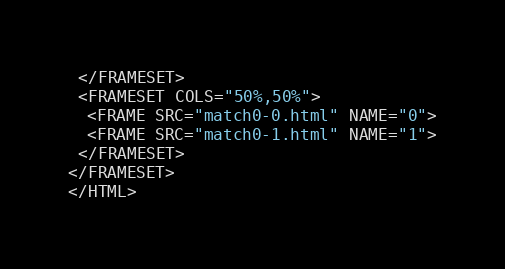<code> <loc_0><loc_0><loc_500><loc_500><_HTML_> </FRAMESET>
 <FRAMESET COLS="50%,50%">
  <FRAME SRC="match0-0.html" NAME="0">
  <FRAME SRC="match0-1.html" NAME="1">
 </FRAMESET>
</FRAMESET>
</HTML>
</code> 